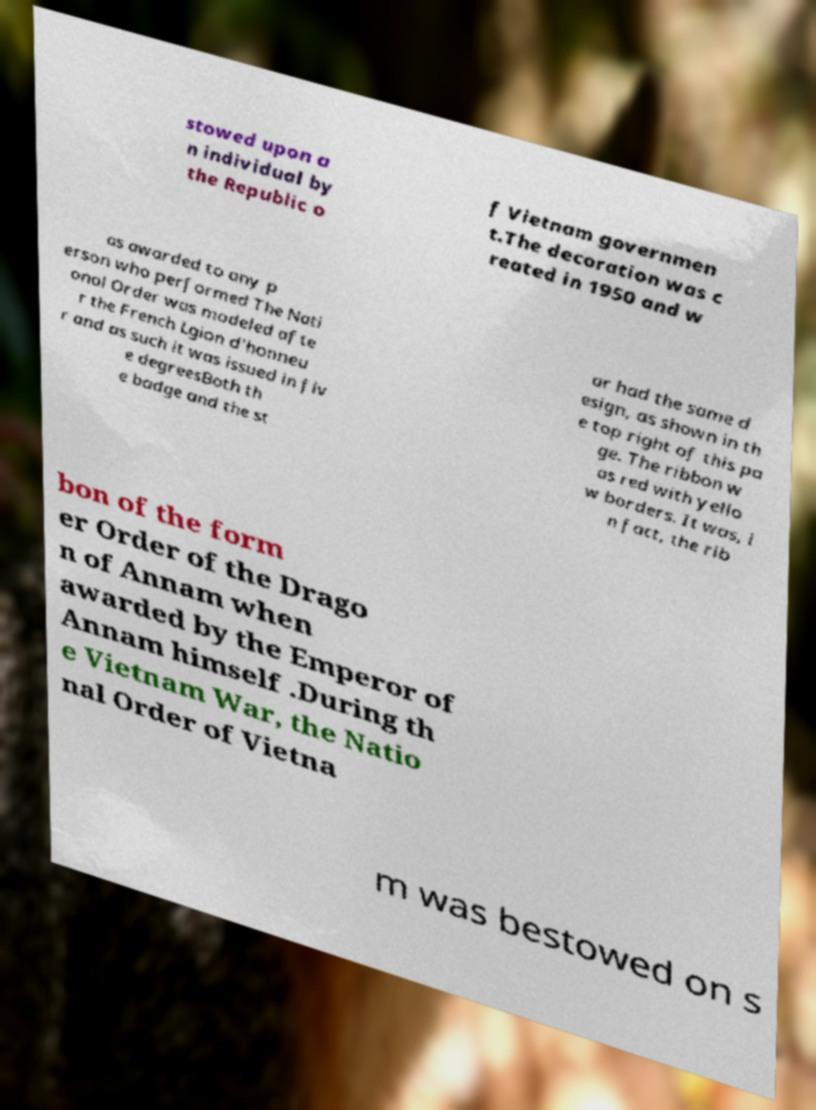Can you read and provide the text displayed in the image?This photo seems to have some interesting text. Can you extract and type it out for me? stowed upon a n individual by the Republic o f Vietnam governmen t.The decoration was c reated in 1950 and w as awarded to any p erson who performed The Nati onal Order was modeled afte r the French Lgion d'honneu r and as such it was issued in fiv e degreesBoth th e badge and the st ar had the same d esign, as shown in th e top right of this pa ge. The ribbon w as red with yello w borders. It was, i n fact, the rib bon of the form er Order of the Drago n of Annam when awarded by the Emperor of Annam himself .During th e Vietnam War, the Natio nal Order of Vietna m was bestowed on s 